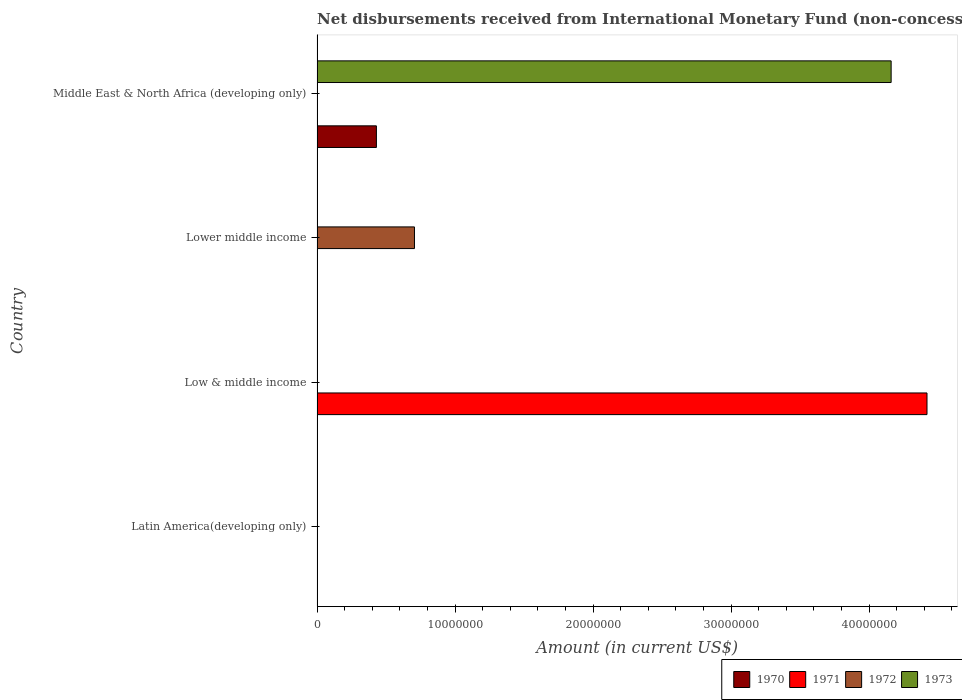How many different coloured bars are there?
Give a very brief answer. 4. Are the number of bars on each tick of the Y-axis equal?
Your response must be concise. No. How many bars are there on the 2nd tick from the bottom?
Offer a very short reply. 1. What is the label of the 3rd group of bars from the top?
Ensure brevity in your answer.  Low & middle income. In how many cases, is the number of bars for a given country not equal to the number of legend labels?
Offer a very short reply. 4. Across all countries, what is the maximum amount of disbursements received from International Monetary Fund in 1973?
Offer a terse response. 4.16e+07. Across all countries, what is the minimum amount of disbursements received from International Monetary Fund in 1972?
Offer a terse response. 0. In which country was the amount of disbursements received from International Monetary Fund in 1971 maximum?
Your response must be concise. Low & middle income. What is the total amount of disbursements received from International Monetary Fund in 1971 in the graph?
Your answer should be compact. 4.42e+07. What is the average amount of disbursements received from International Monetary Fund in 1972 per country?
Give a very brief answer. 1.76e+06. What is the difference between the amount of disbursements received from International Monetary Fund in 1970 and amount of disbursements received from International Monetary Fund in 1973 in Middle East & North Africa (developing only)?
Provide a short and direct response. -3.73e+07. What is the difference between the highest and the lowest amount of disbursements received from International Monetary Fund in 1972?
Your response must be concise. 7.06e+06. Is it the case that in every country, the sum of the amount of disbursements received from International Monetary Fund in 1973 and amount of disbursements received from International Monetary Fund in 1971 is greater than the sum of amount of disbursements received from International Monetary Fund in 1972 and amount of disbursements received from International Monetary Fund in 1970?
Offer a very short reply. No. Is it the case that in every country, the sum of the amount of disbursements received from International Monetary Fund in 1972 and amount of disbursements received from International Monetary Fund in 1971 is greater than the amount of disbursements received from International Monetary Fund in 1970?
Your response must be concise. No. How many legend labels are there?
Your answer should be compact. 4. How are the legend labels stacked?
Your response must be concise. Horizontal. What is the title of the graph?
Provide a succinct answer. Net disbursements received from International Monetary Fund (non-concessional). What is the label or title of the X-axis?
Keep it short and to the point. Amount (in current US$). What is the label or title of the Y-axis?
Provide a short and direct response. Country. What is the Amount (in current US$) in 1971 in Latin America(developing only)?
Your answer should be very brief. 0. What is the Amount (in current US$) in 1970 in Low & middle income?
Your answer should be compact. 0. What is the Amount (in current US$) in 1971 in Low & middle income?
Your answer should be very brief. 4.42e+07. What is the Amount (in current US$) of 1972 in Low & middle income?
Provide a short and direct response. 0. What is the Amount (in current US$) in 1971 in Lower middle income?
Your response must be concise. 0. What is the Amount (in current US$) of 1972 in Lower middle income?
Your response must be concise. 7.06e+06. What is the Amount (in current US$) in 1973 in Lower middle income?
Provide a short and direct response. 0. What is the Amount (in current US$) of 1970 in Middle East & North Africa (developing only)?
Provide a succinct answer. 4.30e+06. What is the Amount (in current US$) of 1972 in Middle East & North Africa (developing only)?
Your answer should be compact. 0. What is the Amount (in current US$) in 1973 in Middle East & North Africa (developing only)?
Your answer should be very brief. 4.16e+07. Across all countries, what is the maximum Amount (in current US$) in 1970?
Ensure brevity in your answer.  4.30e+06. Across all countries, what is the maximum Amount (in current US$) of 1971?
Ensure brevity in your answer.  4.42e+07. Across all countries, what is the maximum Amount (in current US$) of 1972?
Offer a very short reply. 7.06e+06. Across all countries, what is the maximum Amount (in current US$) in 1973?
Keep it short and to the point. 4.16e+07. Across all countries, what is the minimum Amount (in current US$) in 1971?
Ensure brevity in your answer.  0. Across all countries, what is the minimum Amount (in current US$) in 1973?
Your answer should be compact. 0. What is the total Amount (in current US$) of 1970 in the graph?
Your answer should be compact. 4.30e+06. What is the total Amount (in current US$) of 1971 in the graph?
Your answer should be very brief. 4.42e+07. What is the total Amount (in current US$) in 1972 in the graph?
Your answer should be very brief. 7.06e+06. What is the total Amount (in current US$) in 1973 in the graph?
Your response must be concise. 4.16e+07. What is the difference between the Amount (in current US$) in 1971 in Low & middle income and the Amount (in current US$) in 1972 in Lower middle income?
Your answer should be compact. 3.71e+07. What is the difference between the Amount (in current US$) in 1971 in Low & middle income and the Amount (in current US$) in 1973 in Middle East & North Africa (developing only)?
Keep it short and to the point. 2.60e+06. What is the difference between the Amount (in current US$) of 1972 in Lower middle income and the Amount (in current US$) of 1973 in Middle East & North Africa (developing only)?
Offer a very short reply. -3.45e+07. What is the average Amount (in current US$) in 1970 per country?
Provide a succinct answer. 1.08e+06. What is the average Amount (in current US$) in 1971 per country?
Provide a succinct answer. 1.10e+07. What is the average Amount (in current US$) of 1972 per country?
Your response must be concise. 1.76e+06. What is the average Amount (in current US$) of 1973 per country?
Your answer should be compact. 1.04e+07. What is the difference between the Amount (in current US$) in 1970 and Amount (in current US$) in 1973 in Middle East & North Africa (developing only)?
Ensure brevity in your answer.  -3.73e+07. What is the difference between the highest and the lowest Amount (in current US$) in 1970?
Give a very brief answer. 4.30e+06. What is the difference between the highest and the lowest Amount (in current US$) of 1971?
Give a very brief answer. 4.42e+07. What is the difference between the highest and the lowest Amount (in current US$) in 1972?
Ensure brevity in your answer.  7.06e+06. What is the difference between the highest and the lowest Amount (in current US$) in 1973?
Your answer should be compact. 4.16e+07. 